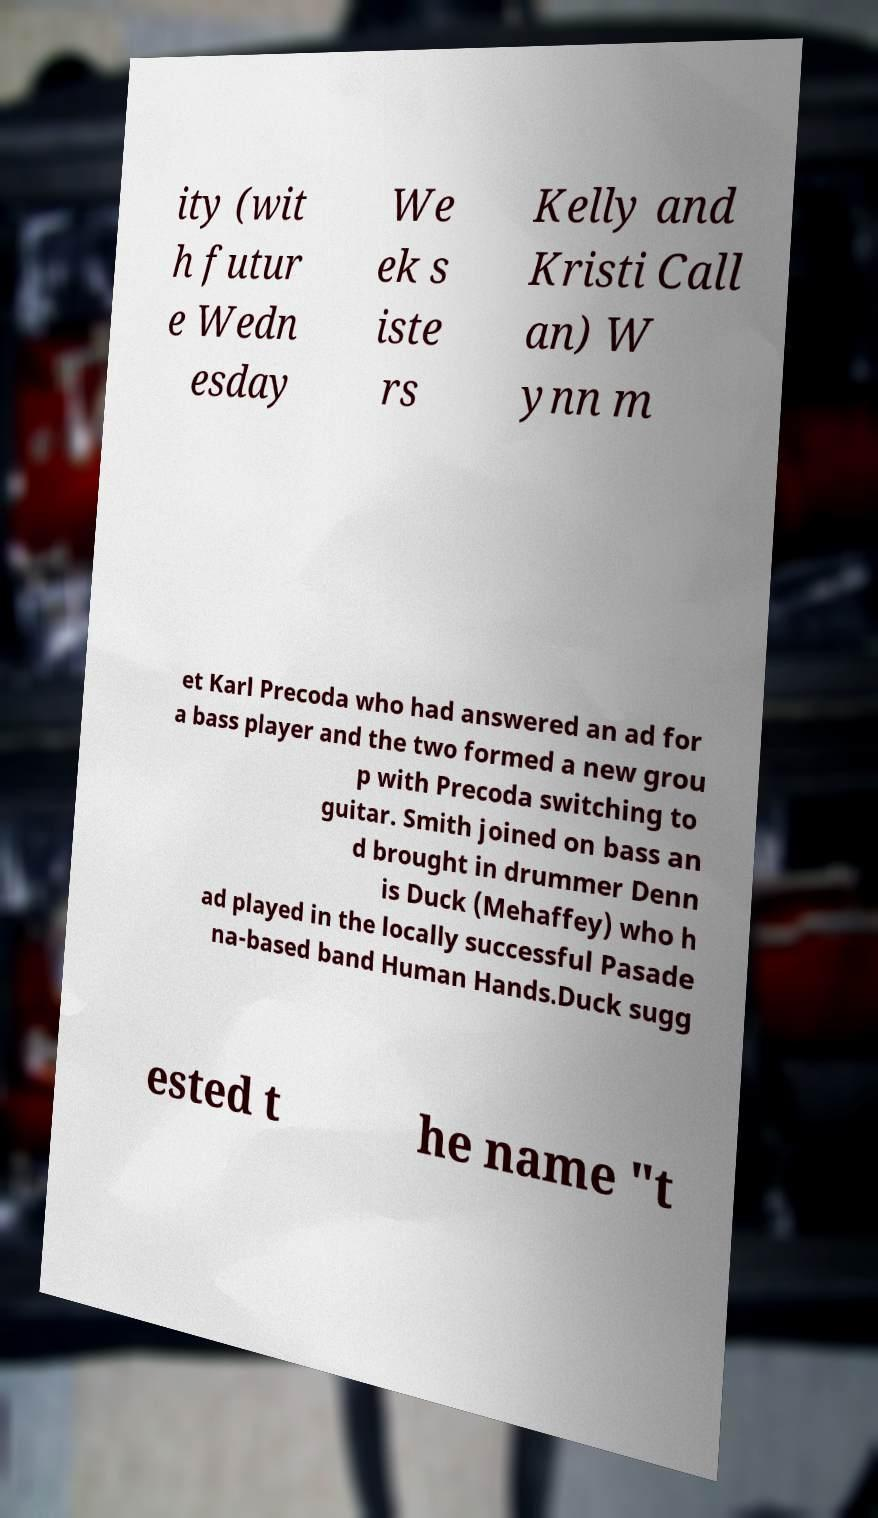Please read and relay the text visible in this image. What does it say? ity (wit h futur e Wedn esday We ek s iste rs Kelly and Kristi Call an) W ynn m et Karl Precoda who had answered an ad for a bass player and the two formed a new grou p with Precoda switching to guitar. Smith joined on bass an d brought in drummer Denn is Duck (Mehaffey) who h ad played in the locally successful Pasade na-based band Human Hands.Duck sugg ested t he name "t 